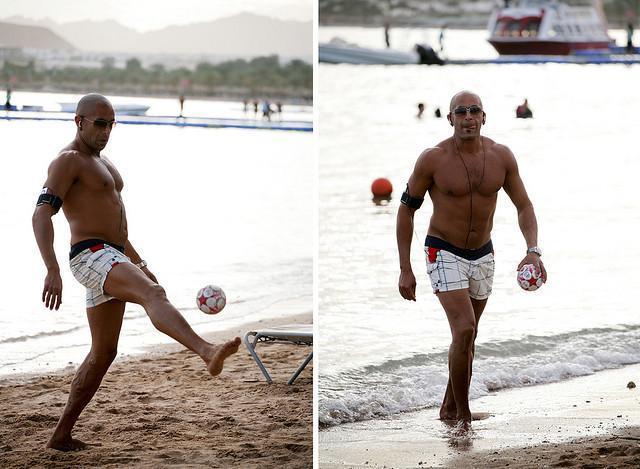How many people are in the picture?
Give a very brief answer. 2. How many people are holding a remote controller?
Give a very brief answer. 0. 